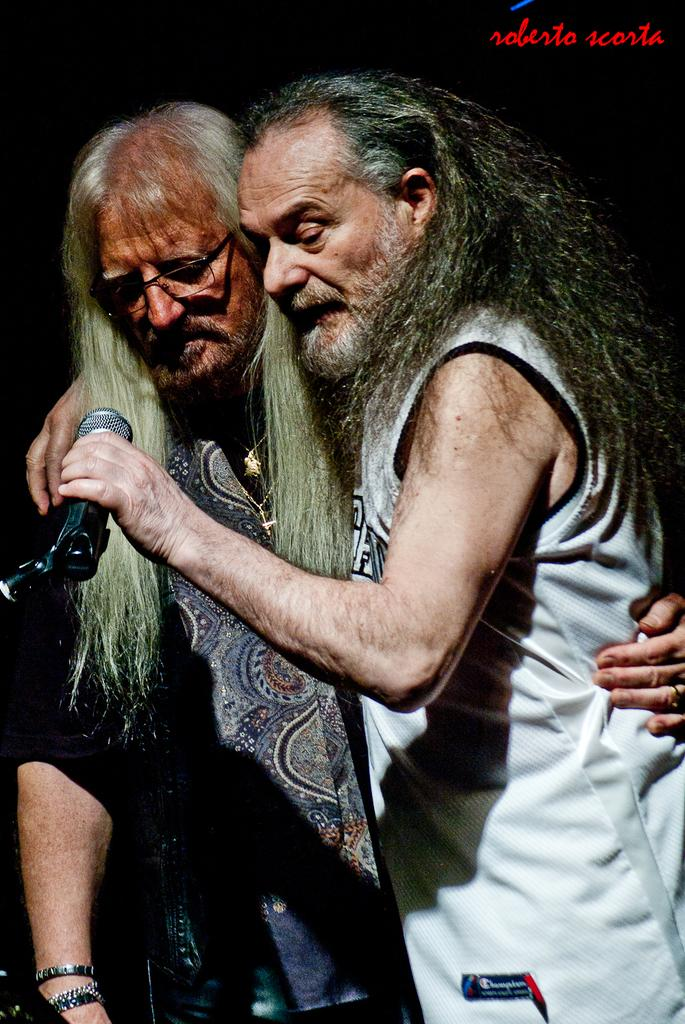How many people are in the image? There are two people in the image. What are the people doing in the image? The people are standing and holding microphones. What can be seen in the background of the image? There is written text in the background of the image. What type of dad is visible in the image? There is no dad present in the image. 